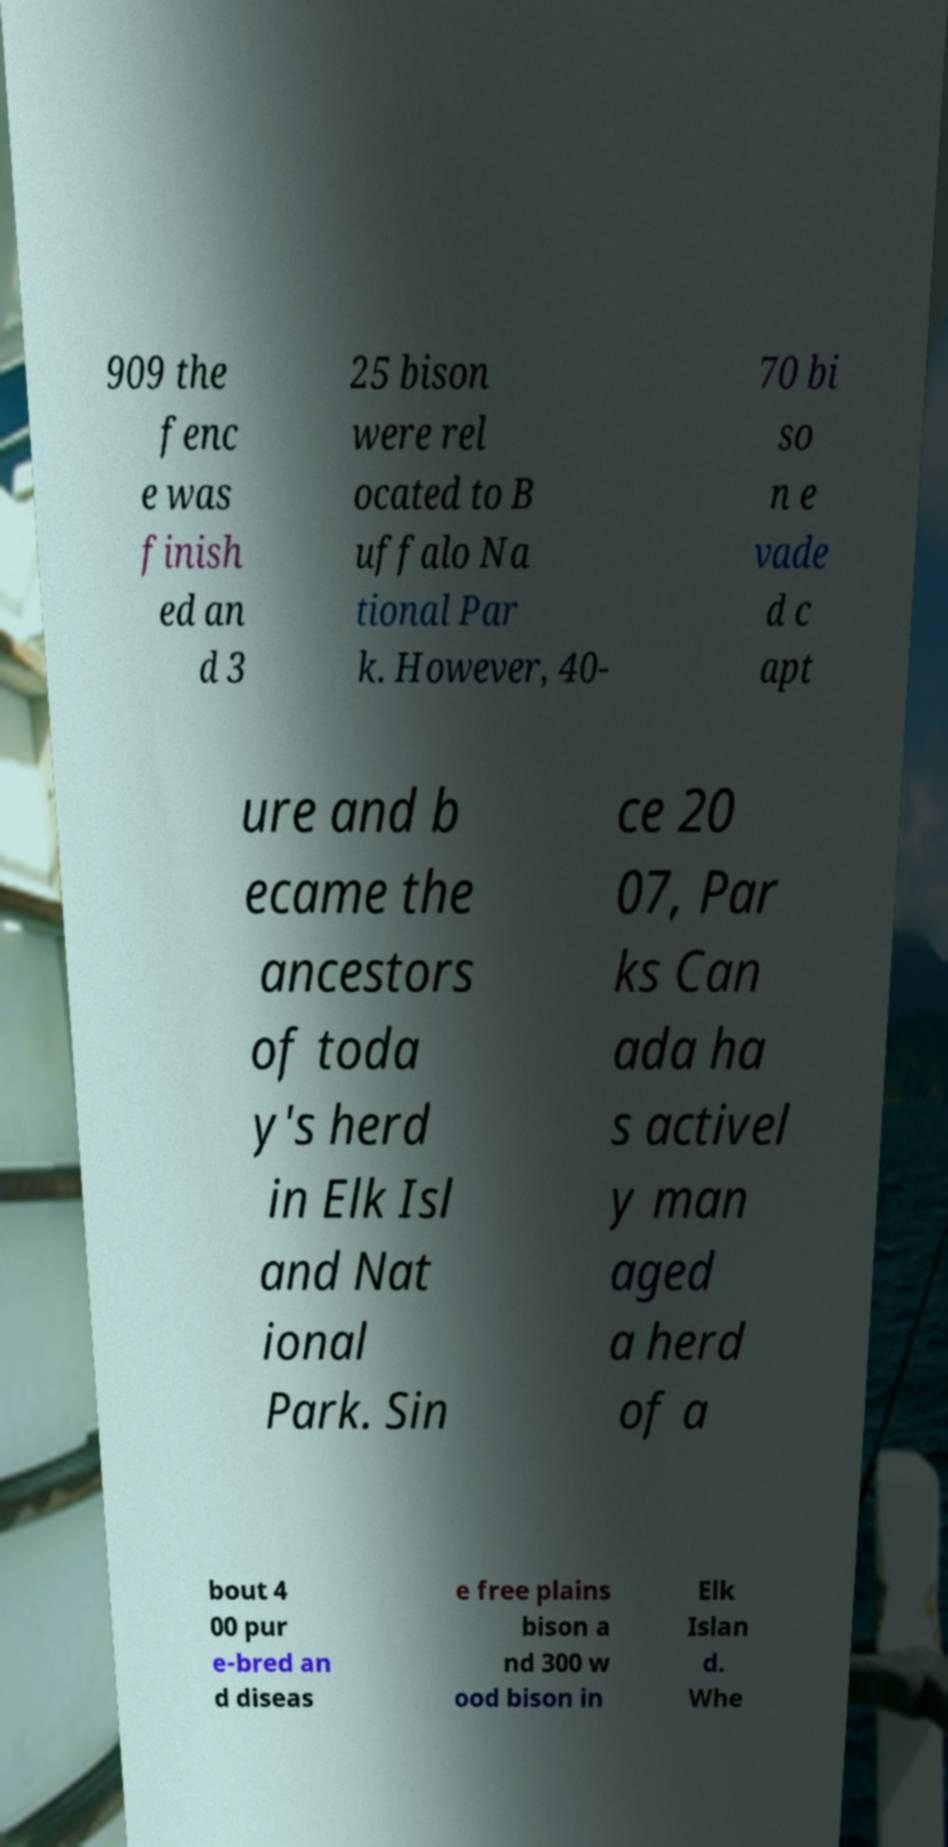Can you read and provide the text displayed in the image?This photo seems to have some interesting text. Can you extract and type it out for me? 909 the fenc e was finish ed an d 3 25 bison were rel ocated to B uffalo Na tional Par k. However, 40- 70 bi so n e vade d c apt ure and b ecame the ancestors of toda y's herd in Elk Isl and Nat ional Park. Sin ce 20 07, Par ks Can ada ha s activel y man aged a herd of a bout 4 00 pur e-bred an d diseas e free plains bison a nd 300 w ood bison in Elk Islan d. Whe 